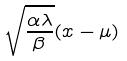Convert formula to latex. <formula><loc_0><loc_0><loc_500><loc_500>\sqrt { \frac { \alpha \lambda } { \beta } } ( x - \mu )</formula> 